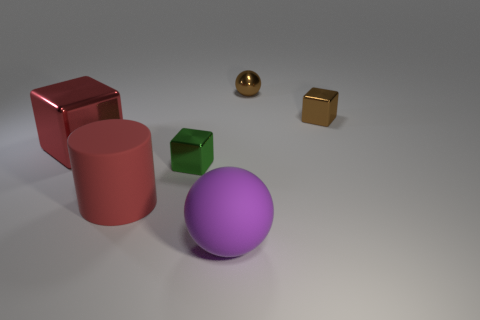Can you describe the lighting in the scene? The lighting in the scene is soft and diffused, coming from an overhead source. The shadows are gentle and help illuminate the shapes of the objects without creating harsh contrasts. 